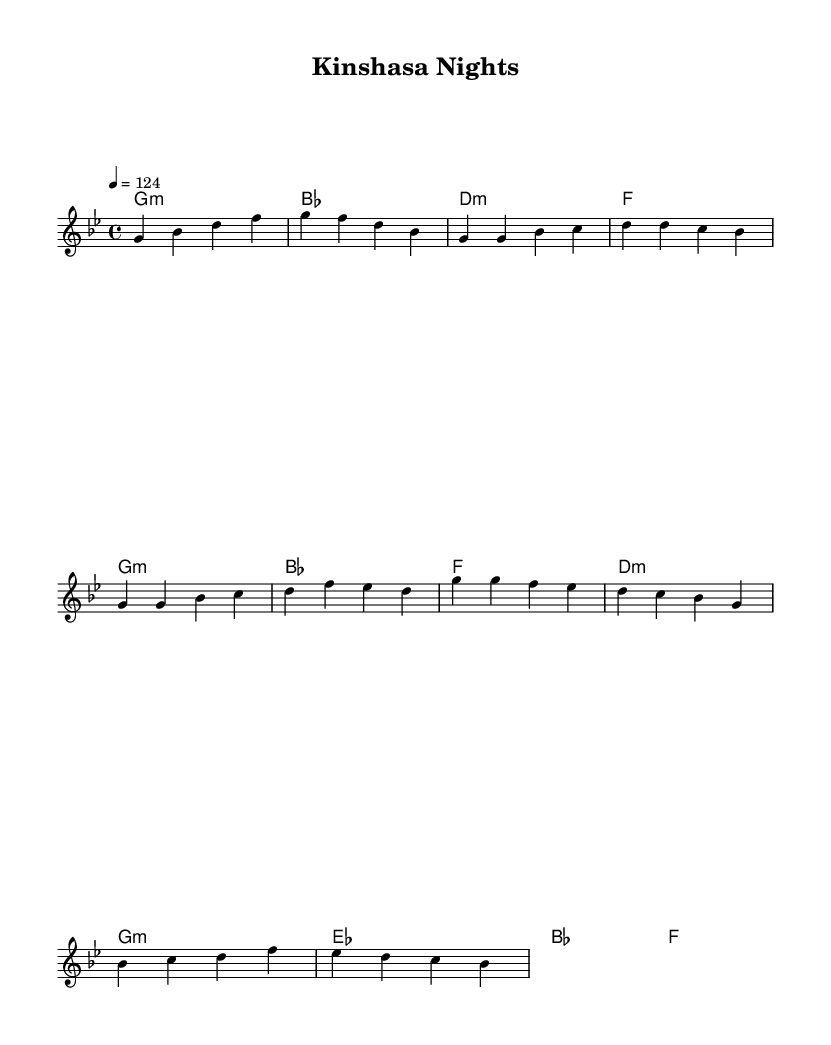What is the key signature of this music? The key signature shows the presence of B flat and E flat, indicating it is in G minor, which is the relative minor of B flat major.
Answer: G minor What is the time signature of this music? The time signature is found at the beginning of the score and displays the number 4 over the number 4, indicating it has four beats per measure.
Answer: 4/4 What is the tempo marking for this piece? The tempo marking indicates that the piece should be played at a speed of 124 beats per minute, which is shown by the number provided in the tempo indication.
Answer: 124 How many measures are there in the melody section? By counting the groups of notes separated by bar lines in the melody part, we find that there are 12 measures in total within the provided melody section.
Answer: 12 What type of chord is played in the introduction? The introduction begins with a G minor chord, which is indicated as "g1:m" in the harmonies section, signaling its quality and root note.
Answer: G minor Which section of the piece features a refrain of the melody? The section labeled as the "Chorus" contains a repetition of melodic themes, which can be identified by the specific grouping of measures and the change in musical dynamics comparing to the verse.
Answer: Chorus What influences can be traced in this piece? The fusion of Iyenga-inspired African rhythmic elements and Western pop influences can be identified through the dance-oriented tempo and structure that mimics common pop song forms.
Answer: Fusion influences 